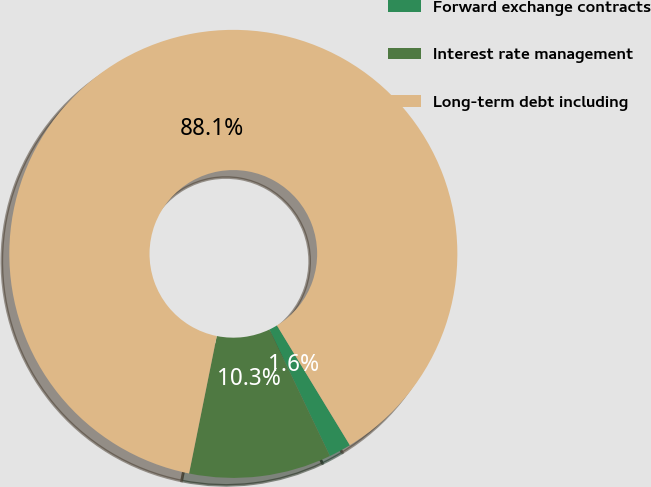Convert chart to OTSL. <chart><loc_0><loc_0><loc_500><loc_500><pie_chart><fcel>Forward exchange contracts<fcel>Interest rate management<fcel>Long-term debt including<nl><fcel>1.61%<fcel>10.26%<fcel>88.12%<nl></chart> 